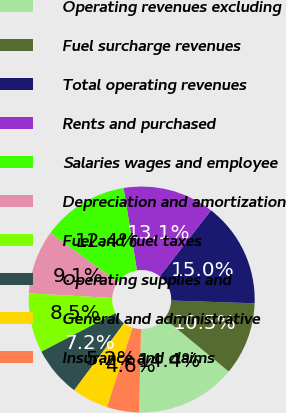Convert chart. <chart><loc_0><loc_0><loc_500><loc_500><pie_chart><fcel>Operating revenues excluding<fcel>Fuel surcharge revenues<fcel>Total operating revenues<fcel>Rents and purchased<fcel>Salaries wages and employee<fcel>Depreciation and amortization<fcel>Fuel and fuel taxes<fcel>Operating supplies and<fcel>General and administrative<fcel>Insurance and claims<nl><fcel>14.38%<fcel>10.46%<fcel>15.03%<fcel>13.07%<fcel>12.42%<fcel>9.15%<fcel>8.5%<fcel>7.19%<fcel>5.23%<fcel>4.58%<nl></chart> 